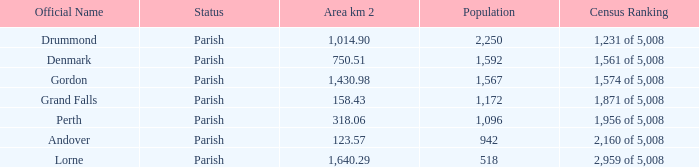Which parish has an area of 750.51? Denmark. 